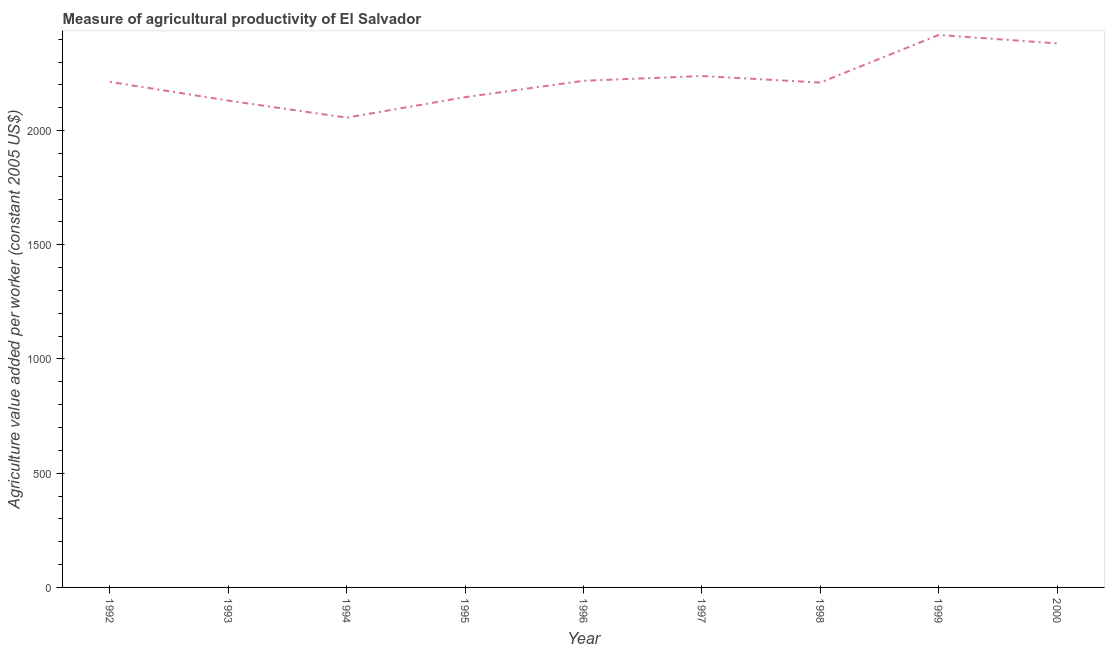What is the agriculture value added per worker in 2000?
Offer a terse response. 2381.6. Across all years, what is the maximum agriculture value added per worker?
Provide a short and direct response. 2418.57. Across all years, what is the minimum agriculture value added per worker?
Provide a succinct answer. 2056.51. In which year was the agriculture value added per worker minimum?
Your answer should be compact. 1994. What is the sum of the agriculture value added per worker?
Offer a terse response. 2.00e+04. What is the difference between the agriculture value added per worker in 1993 and 1994?
Offer a terse response. 74.61. What is the average agriculture value added per worker per year?
Offer a terse response. 2223.81. What is the median agriculture value added per worker?
Your answer should be very brief. 2213.23. In how many years, is the agriculture value added per worker greater than 1100 US$?
Make the answer very short. 9. What is the ratio of the agriculture value added per worker in 1992 to that in 1996?
Give a very brief answer. 1. Is the agriculture value added per worker in 1993 less than that in 1995?
Provide a succinct answer. Yes. What is the difference between the highest and the second highest agriculture value added per worker?
Make the answer very short. 36.97. Is the sum of the agriculture value added per worker in 1993 and 1999 greater than the maximum agriculture value added per worker across all years?
Your answer should be compact. Yes. What is the difference between the highest and the lowest agriculture value added per worker?
Ensure brevity in your answer.  362.06. How many lines are there?
Keep it short and to the point. 1. How many years are there in the graph?
Offer a terse response. 9. What is the difference between two consecutive major ticks on the Y-axis?
Offer a terse response. 500. Does the graph contain grids?
Your response must be concise. No. What is the title of the graph?
Give a very brief answer. Measure of agricultural productivity of El Salvador. What is the label or title of the Y-axis?
Keep it short and to the point. Agriculture value added per worker (constant 2005 US$). What is the Agriculture value added per worker (constant 2005 US$) of 1992?
Your answer should be very brief. 2213.23. What is the Agriculture value added per worker (constant 2005 US$) in 1993?
Your answer should be very brief. 2131.11. What is the Agriculture value added per worker (constant 2005 US$) in 1994?
Your answer should be compact. 2056.51. What is the Agriculture value added per worker (constant 2005 US$) of 1995?
Keep it short and to the point. 2146.31. What is the Agriculture value added per worker (constant 2005 US$) in 1996?
Your answer should be compact. 2217.96. What is the Agriculture value added per worker (constant 2005 US$) of 1997?
Provide a short and direct response. 2238.79. What is the Agriculture value added per worker (constant 2005 US$) in 1998?
Provide a succinct answer. 2210.23. What is the Agriculture value added per worker (constant 2005 US$) in 1999?
Offer a very short reply. 2418.57. What is the Agriculture value added per worker (constant 2005 US$) in 2000?
Your response must be concise. 2381.6. What is the difference between the Agriculture value added per worker (constant 2005 US$) in 1992 and 1993?
Give a very brief answer. 82.12. What is the difference between the Agriculture value added per worker (constant 2005 US$) in 1992 and 1994?
Give a very brief answer. 156.72. What is the difference between the Agriculture value added per worker (constant 2005 US$) in 1992 and 1995?
Keep it short and to the point. 66.92. What is the difference between the Agriculture value added per worker (constant 2005 US$) in 1992 and 1996?
Offer a terse response. -4.73. What is the difference between the Agriculture value added per worker (constant 2005 US$) in 1992 and 1997?
Give a very brief answer. -25.56. What is the difference between the Agriculture value added per worker (constant 2005 US$) in 1992 and 1998?
Give a very brief answer. 3. What is the difference between the Agriculture value added per worker (constant 2005 US$) in 1992 and 1999?
Provide a succinct answer. -205.34. What is the difference between the Agriculture value added per worker (constant 2005 US$) in 1992 and 2000?
Offer a terse response. -168.37. What is the difference between the Agriculture value added per worker (constant 2005 US$) in 1993 and 1994?
Your answer should be compact. 74.61. What is the difference between the Agriculture value added per worker (constant 2005 US$) in 1993 and 1995?
Offer a terse response. -15.2. What is the difference between the Agriculture value added per worker (constant 2005 US$) in 1993 and 1996?
Ensure brevity in your answer.  -86.84. What is the difference between the Agriculture value added per worker (constant 2005 US$) in 1993 and 1997?
Keep it short and to the point. -107.68. What is the difference between the Agriculture value added per worker (constant 2005 US$) in 1993 and 1998?
Offer a terse response. -79.12. What is the difference between the Agriculture value added per worker (constant 2005 US$) in 1993 and 1999?
Ensure brevity in your answer.  -287.46. What is the difference between the Agriculture value added per worker (constant 2005 US$) in 1993 and 2000?
Provide a succinct answer. -250.49. What is the difference between the Agriculture value added per worker (constant 2005 US$) in 1994 and 1995?
Ensure brevity in your answer.  -89.8. What is the difference between the Agriculture value added per worker (constant 2005 US$) in 1994 and 1996?
Keep it short and to the point. -161.45. What is the difference between the Agriculture value added per worker (constant 2005 US$) in 1994 and 1997?
Offer a very short reply. -182.28. What is the difference between the Agriculture value added per worker (constant 2005 US$) in 1994 and 1998?
Make the answer very short. -153.73. What is the difference between the Agriculture value added per worker (constant 2005 US$) in 1994 and 1999?
Offer a very short reply. -362.06. What is the difference between the Agriculture value added per worker (constant 2005 US$) in 1994 and 2000?
Ensure brevity in your answer.  -325.1. What is the difference between the Agriculture value added per worker (constant 2005 US$) in 1995 and 1996?
Give a very brief answer. -71.64. What is the difference between the Agriculture value added per worker (constant 2005 US$) in 1995 and 1997?
Ensure brevity in your answer.  -92.48. What is the difference between the Agriculture value added per worker (constant 2005 US$) in 1995 and 1998?
Make the answer very short. -63.92. What is the difference between the Agriculture value added per worker (constant 2005 US$) in 1995 and 1999?
Your answer should be compact. -272.26. What is the difference between the Agriculture value added per worker (constant 2005 US$) in 1995 and 2000?
Your answer should be compact. -235.29. What is the difference between the Agriculture value added per worker (constant 2005 US$) in 1996 and 1997?
Offer a terse response. -20.83. What is the difference between the Agriculture value added per worker (constant 2005 US$) in 1996 and 1998?
Provide a succinct answer. 7.72. What is the difference between the Agriculture value added per worker (constant 2005 US$) in 1996 and 1999?
Offer a very short reply. -200.62. What is the difference between the Agriculture value added per worker (constant 2005 US$) in 1996 and 2000?
Offer a very short reply. -163.65. What is the difference between the Agriculture value added per worker (constant 2005 US$) in 1997 and 1998?
Your response must be concise. 28.56. What is the difference between the Agriculture value added per worker (constant 2005 US$) in 1997 and 1999?
Your response must be concise. -179.78. What is the difference between the Agriculture value added per worker (constant 2005 US$) in 1997 and 2000?
Offer a terse response. -142.81. What is the difference between the Agriculture value added per worker (constant 2005 US$) in 1998 and 1999?
Make the answer very short. -208.34. What is the difference between the Agriculture value added per worker (constant 2005 US$) in 1998 and 2000?
Offer a very short reply. -171.37. What is the difference between the Agriculture value added per worker (constant 2005 US$) in 1999 and 2000?
Offer a terse response. 36.97. What is the ratio of the Agriculture value added per worker (constant 2005 US$) in 1992 to that in 1993?
Make the answer very short. 1.04. What is the ratio of the Agriculture value added per worker (constant 2005 US$) in 1992 to that in 1994?
Ensure brevity in your answer.  1.08. What is the ratio of the Agriculture value added per worker (constant 2005 US$) in 1992 to that in 1995?
Offer a very short reply. 1.03. What is the ratio of the Agriculture value added per worker (constant 2005 US$) in 1992 to that in 1997?
Offer a terse response. 0.99. What is the ratio of the Agriculture value added per worker (constant 2005 US$) in 1992 to that in 1998?
Offer a very short reply. 1. What is the ratio of the Agriculture value added per worker (constant 2005 US$) in 1992 to that in 1999?
Offer a terse response. 0.92. What is the ratio of the Agriculture value added per worker (constant 2005 US$) in 1992 to that in 2000?
Offer a very short reply. 0.93. What is the ratio of the Agriculture value added per worker (constant 2005 US$) in 1993 to that in 1994?
Provide a succinct answer. 1.04. What is the ratio of the Agriculture value added per worker (constant 2005 US$) in 1993 to that in 1996?
Offer a very short reply. 0.96. What is the ratio of the Agriculture value added per worker (constant 2005 US$) in 1993 to that in 1997?
Your response must be concise. 0.95. What is the ratio of the Agriculture value added per worker (constant 2005 US$) in 1993 to that in 1998?
Provide a succinct answer. 0.96. What is the ratio of the Agriculture value added per worker (constant 2005 US$) in 1993 to that in 1999?
Provide a short and direct response. 0.88. What is the ratio of the Agriculture value added per worker (constant 2005 US$) in 1993 to that in 2000?
Provide a succinct answer. 0.9. What is the ratio of the Agriculture value added per worker (constant 2005 US$) in 1994 to that in 1995?
Your response must be concise. 0.96. What is the ratio of the Agriculture value added per worker (constant 2005 US$) in 1994 to that in 1996?
Ensure brevity in your answer.  0.93. What is the ratio of the Agriculture value added per worker (constant 2005 US$) in 1994 to that in 1997?
Give a very brief answer. 0.92. What is the ratio of the Agriculture value added per worker (constant 2005 US$) in 1994 to that in 1998?
Your answer should be very brief. 0.93. What is the ratio of the Agriculture value added per worker (constant 2005 US$) in 1994 to that in 2000?
Keep it short and to the point. 0.86. What is the ratio of the Agriculture value added per worker (constant 2005 US$) in 1995 to that in 1996?
Keep it short and to the point. 0.97. What is the ratio of the Agriculture value added per worker (constant 2005 US$) in 1995 to that in 1997?
Your answer should be compact. 0.96. What is the ratio of the Agriculture value added per worker (constant 2005 US$) in 1995 to that in 1999?
Keep it short and to the point. 0.89. What is the ratio of the Agriculture value added per worker (constant 2005 US$) in 1995 to that in 2000?
Ensure brevity in your answer.  0.9. What is the ratio of the Agriculture value added per worker (constant 2005 US$) in 1996 to that in 1997?
Your answer should be very brief. 0.99. What is the ratio of the Agriculture value added per worker (constant 2005 US$) in 1996 to that in 1998?
Provide a short and direct response. 1. What is the ratio of the Agriculture value added per worker (constant 2005 US$) in 1996 to that in 1999?
Give a very brief answer. 0.92. What is the ratio of the Agriculture value added per worker (constant 2005 US$) in 1996 to that in 2000?
Your response must be concise. 0.93. What is the ratio of the Agriculture value added per worker (constant 2005 US$) in 1997 to that in 1998?
Keep it short and to the point. 1.01. What is the ratio of the Agriculture value added per worker (constant 2005 US$) in 1997 to that in 1999?
Ensure brevity in your answer.  0.93. What is the ratio of the Agriculture value added per worker (constant 2005 US$) in 1997 to that in 2000?
Ensure brevity in your answer.  0.94. What is the ratio of the Agriculture value added per worker (constant 2005 US$) in 1998 to that in 1999?
Offer a very short reply. 0.91. What is the ratio of the Agriculture value added per worker (constant 2005 US$) in 1998 to that in 2000?
Provide a short and direct response. 0.93. What is the ratio of the Agriculture value added per worker (constant 2005 US$) in 1999 to that in 2000?
Provide a short and direct response. 1.02. 